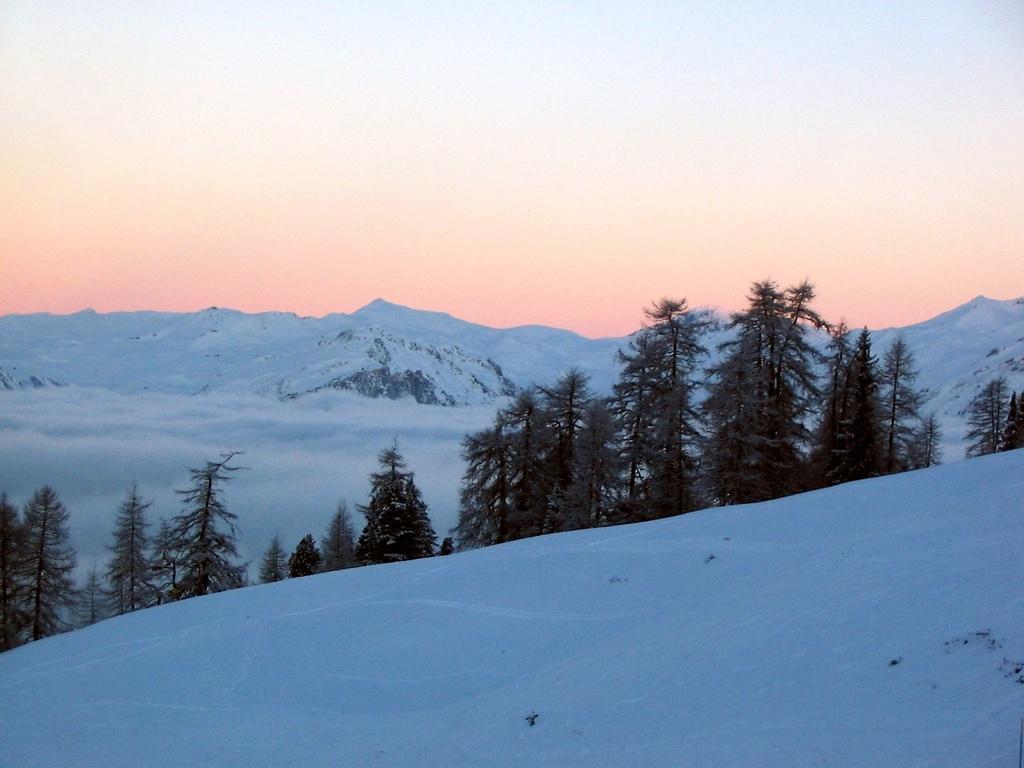Can you describe this image briefly? In this image there are trees and we can see snow. In the background there are mountains and sky. 